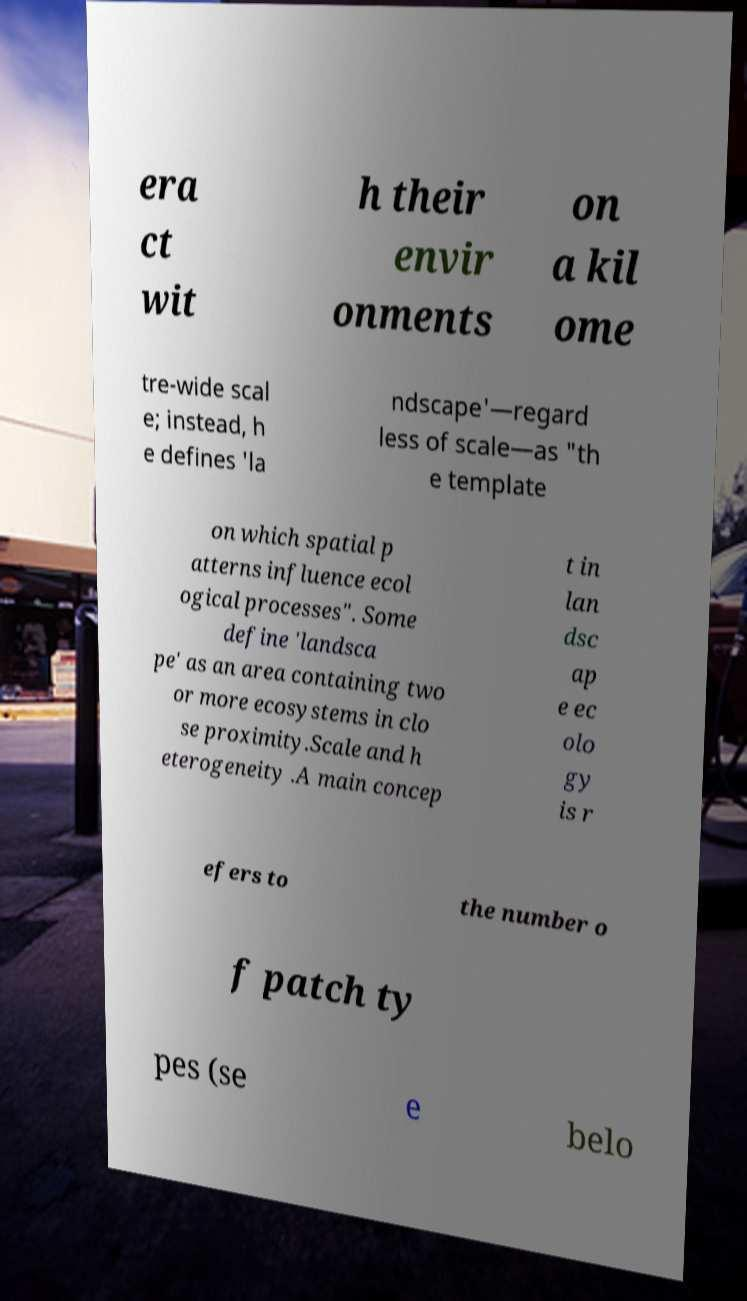For documentation purposes, I need the text within this image transcribed. Could you provide that? era ct wit h their envir onments on a kil ome tre-wide scal e; instead, h e defines 'la ndscape'—regard less of scale—as "th e template on which spatial p atterns influence ecol ogical processes". Some define 'landsca pe' as an area containing two or more ecosystems in clo se proximity.Scale and h eterogeneity .A main concep t in lan dsc ap e ec olo gy is r efers to the number o f patch ty pes (se e belo 